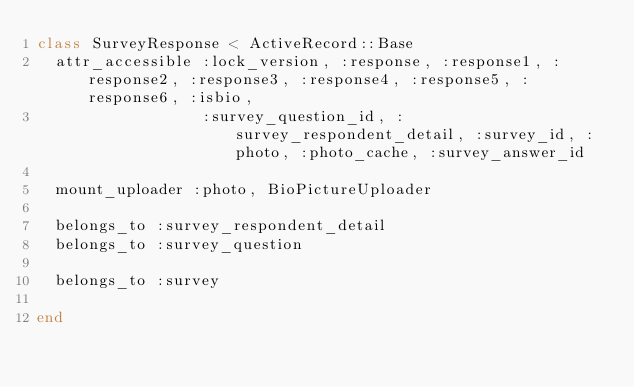<code> <loc_0><loc_0><loc_500><loc_500><_Ruby_>class SurveyResponse < ActiveRecord::Base
  attr_accessible :lock_version, :response, :response1, :response2, :response3, :response4, :response5, :response6, :isbio,
                  :survey_question_id, :survey_respondent_detail, :survey_id, :photo, :photo_cache, :survey_answer_id

  mount_uploader :photo, BioPictureUploader

  belongs_to :survey_respondent_detail
  belongs_to :survey_question
  
  belongs_to :survey
  
end
</code> 